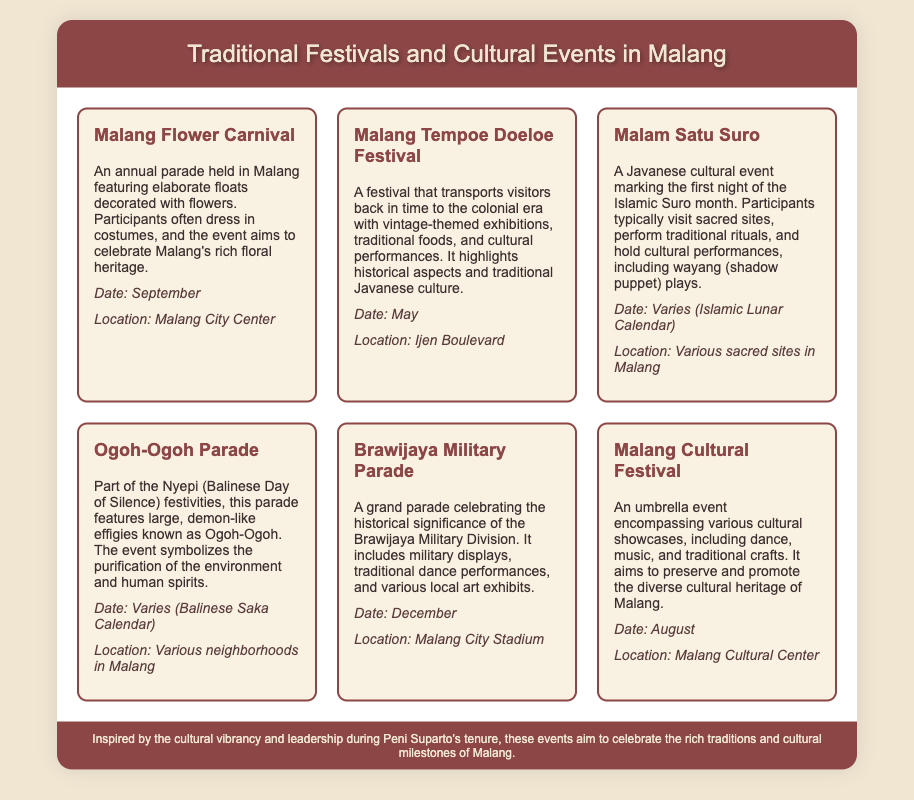What is the first event listed in the calendar? The first event listed is the Malang Flower Carnival as seen at the top of the document.
Answer: Malang Flower Carnival During which month is the Malang Tempoe Doeloe Festival held? The document explicitly states that the Malang Tempoe Doeloe Festival is held in May.
Answer: May What type of performances are part of the Malam Satu Suro event? The document mentions that wayang (shadow puppet) plays are included in the cultural performances of the Malam Satu Suro event.
Answer: Wayang How many events are scheduled in December? The document lists one event (Brawijaya Military Parade) scheduled in December.
Answer: 1 Which location holds the Malang Cultural Festival? The document states that the Malang Cultural Festival takes place at the Malang Cultural Center.
Answer: Malang Cultural Center What is the symbolic purpose of the Ogoh-Ogoh Parade? The document describes the Ogoh-Ogoh Parade as symbolizing the purification of the environment and human spirits.
Answer: Purification Which event is celebrated with military displays? The event that includes military displays is the Brawijaya Military Parade, as indicated in the document.
Answer: Brawijaya Military Parade What month does the Malang Flower Carnival take place? According to the document, the Malang Flower Carnival takes place in September.
Answer: September 